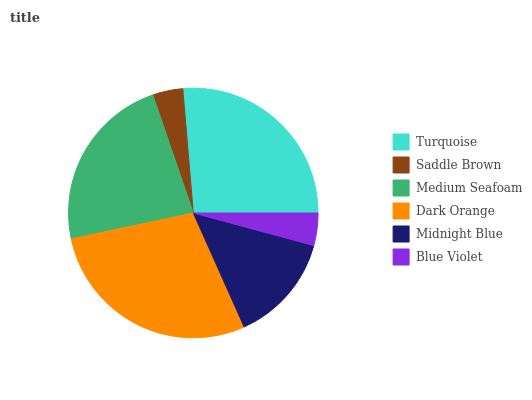Is Saddle Brown the minimum?
Answer yes or no. Yes. Is Dark Orange the maximum?
Answer yes or no. Yes. Is Medium Seafoam the minimum?
Answer yes or no. No. Is Medium Seafoam the maximum?
Answer yes or no. No. Is Medium Seafoam greater than Saddle Brown?
Answer yes or no. Yes. Is Saddle Brown less than Medium Seafoam?
Answer yes or no. Yes. Is Saddle Brown greater than Medium Seafoam?
Answer yes or no. No. Is Medium Seafoam less than Saddle Brown?
Answer yes or no. No. Is Medium Seafoam the high median?
Answer yes or no. Yes. Is Midnight Blue the low median?
Answer yes or no. Yes. Is Midnight Blue the high median?
Answer yes or no. No. Is Turquoise the low median?
Answer yes or no. No. 